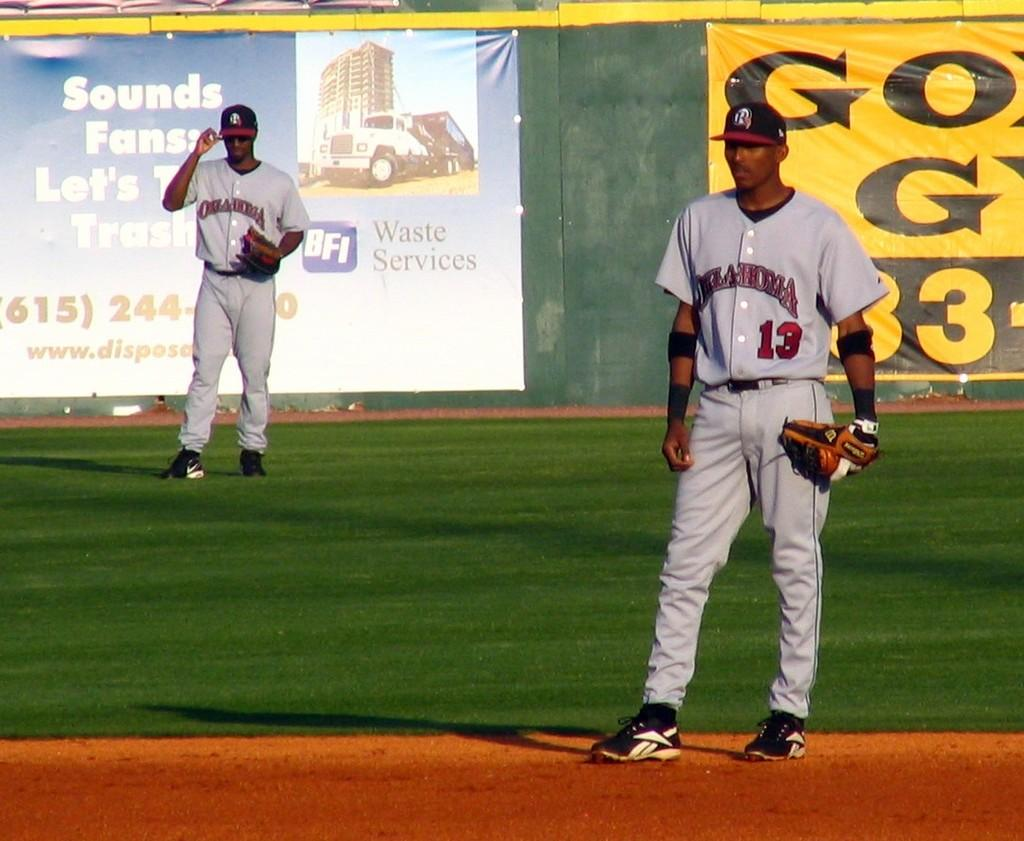<image>
Create a compact narrative representing the image presented. Two men wearing Oklahoma jerseys waiting on the field. 